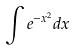Convert formula to latex. <formula><loc_0><loc_0><loc_500><loc_500>\int e ^ { - x ^ { 2 } } d x</formula> 